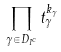<formula> <loc_0><loc_0><loc_500><loc_500>\prod _ { \gamma \in D _ { I ^ { c } } } t _ { \gamma } ^ { k _ { \gamma } }</formula> 